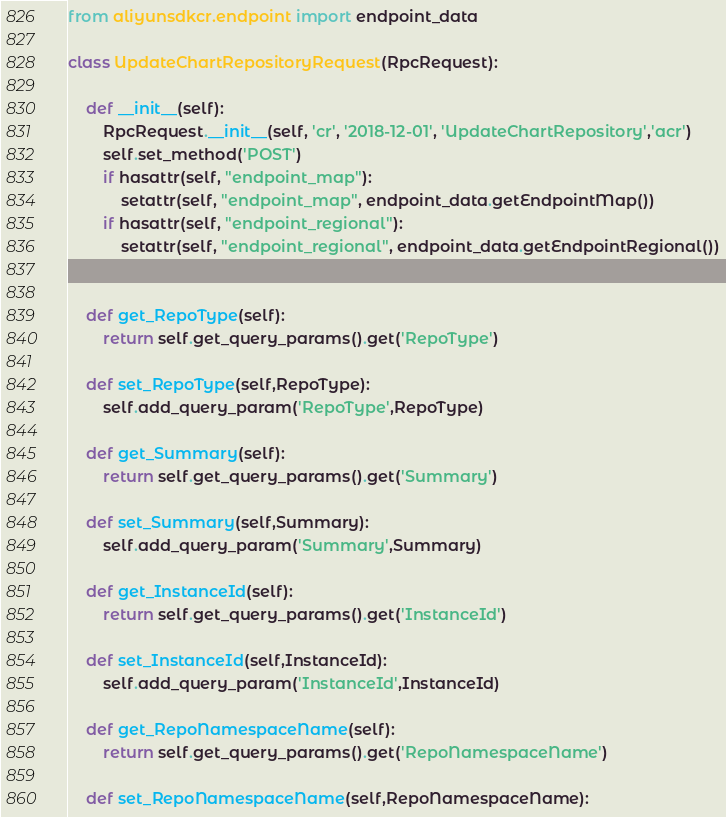Convert code to text. <code><loc_0><loc_0><loc_500><loc_500><_Python_>from aliyunsdkcr.endpoint import endpoint_data

class UpdateChartRepositoryRequest(RpcRequest):

	def __init__(self):
		RpcRequest.__init__(self, 'cr', '2018-12-01', 'UpdateChartRepository','acr')
		self.set_method('POST')
		if hasattr(self, "endpoint_map"):
			setattr(self, "endpoint_map", endpoint_data.getEndpointMap())
		if hasattr(self, "endpoint_regional"):
			setattr(self, "endpoint_regional", endpoint_data.getEndpointRegional())


	def get_RepoType(self):
		return self.get_query_params().get('RepoType')

	def set_RepoType(self,RepoType):
		self.add_query_param('RepoType',RepoType)

	def get_Summary(self):
		return self.get_query_params().get('Summary')

	def set_Summary(self,Summary):
		self.add_query_param('Summary',Summary)

	def get_InstanceId(self):
		return self.get_query_params().get('InstanceId')

	def set_InstanceId(self,InstanceId):
		self.add_query_param('InstanceId',InstanceId)

	def get_RepoNamespaceName(self):
		return self.get_query_params().get('RepoNamespaceName')

	def set_RepoNamespaceName(self,RepoNamespaceName):</code> 